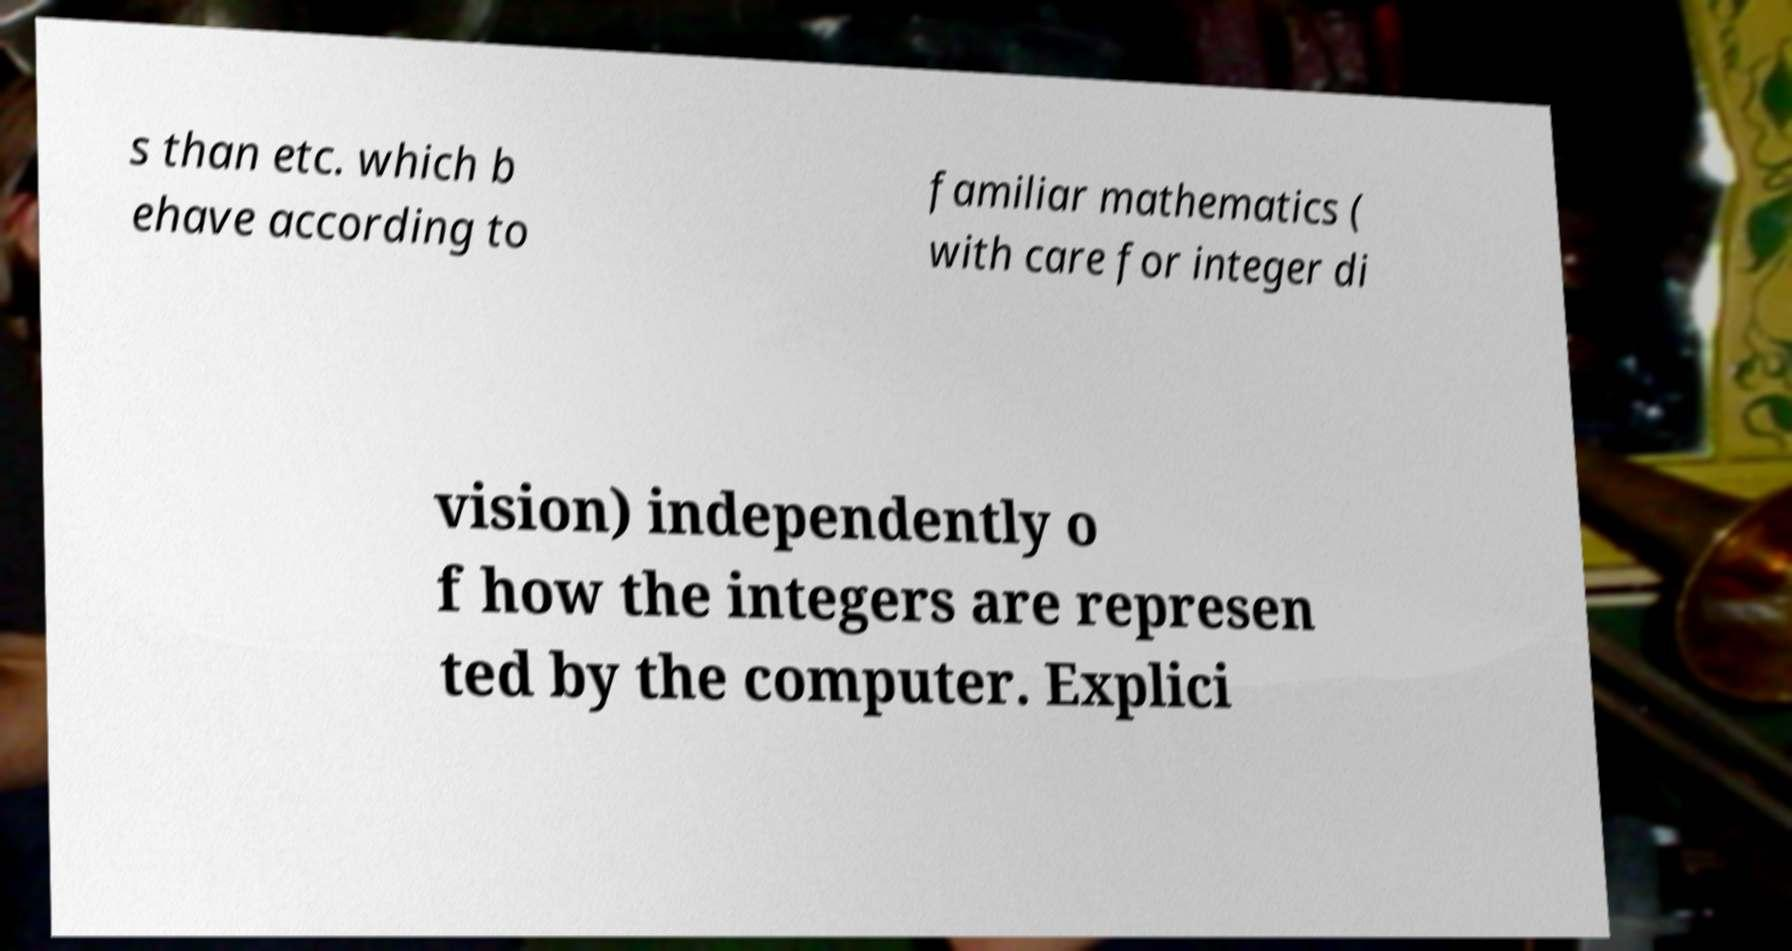Can you accurately transcribe the text from the provided image for me? s than etc. which b ehave according to familiar mathematics ( with care for integer di vision) independently o f how the integers are represen ted by the computer. Explici 